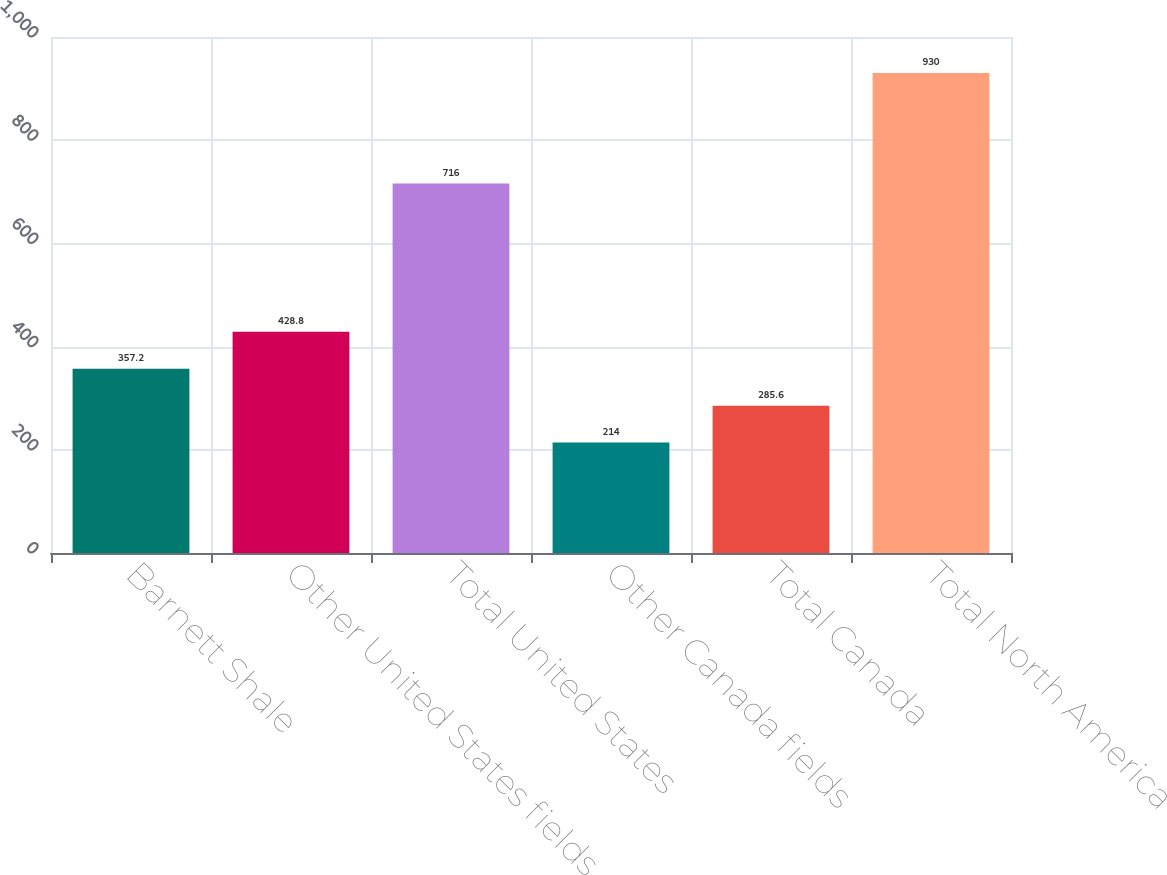<chart> <loc_0><loc_0><loc_500><loc_500><bar_chart><fcel>Barnett Shale<fcel>Other United States fields<fcel>Total United States<fcel>Other Canada fields<fcel>Total Canada<fcel>Total North America<nl><fcel>357.2<fcel>428.8<fcel>716<fcel>214<fcel>285.6<fcel>930<nl></chart> 